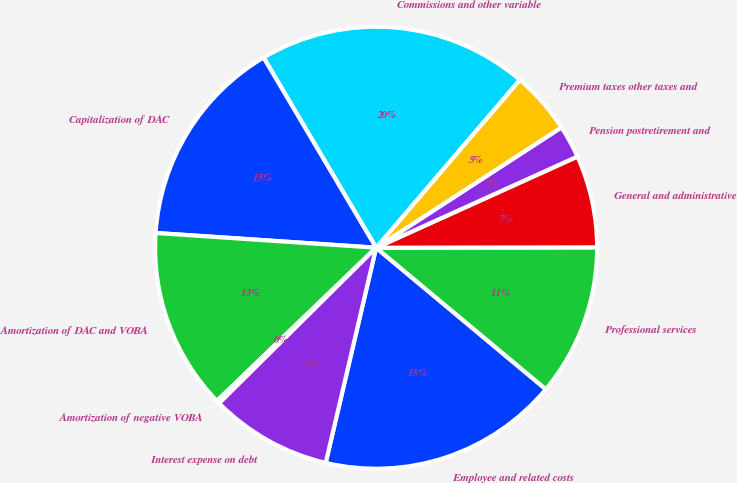Convert chart to OTSL. <chart><loc_0><loc_0><loc_500><loc_500><pie_chart><fcel>Employee and related costs<fcel>Professional services<fcel>General and administrative<fcel>Pension postretirement and<fcel>Premium taxes other taxes and<fcel>Commissions and other variable<fcel>Capitalization of DAC<fcel>Amortization of DAC and VOBA<fcel>Amortization of negative VOBA<fcel>Interest expense on debt<nl><fcel>17.6%<fcel>11.09%<fcel>6.74%<fcel>2.4%<fcel>4.57%<fcel>19.77%<fcel>15.43%<fcel>13.26%<fcel>0.23%<fcel>8.91%<nl></chart> 